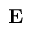<formula> <loc_0><loc_0><loc_500><loc_500>E</formula> 